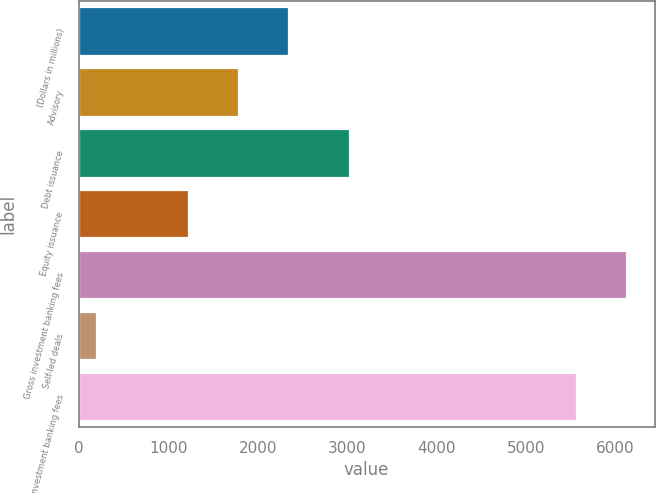<chart> <loc_0><loc_0><loc_500><loc_500><bar_chart><fcel>(Dollars in millions)<fcel>Advisory<fcel>Debt issuance<fcel>Equity issuance<fcel>Gross investment banking fees<fcel>Self-led deals<fcel>Total investment banking fees<nl><fcel>2350.4<fcel>1793.2<fcel>3033<fcel>1236<fcel>6129.2<fcel>200<fcel>5572<nl></chart> 